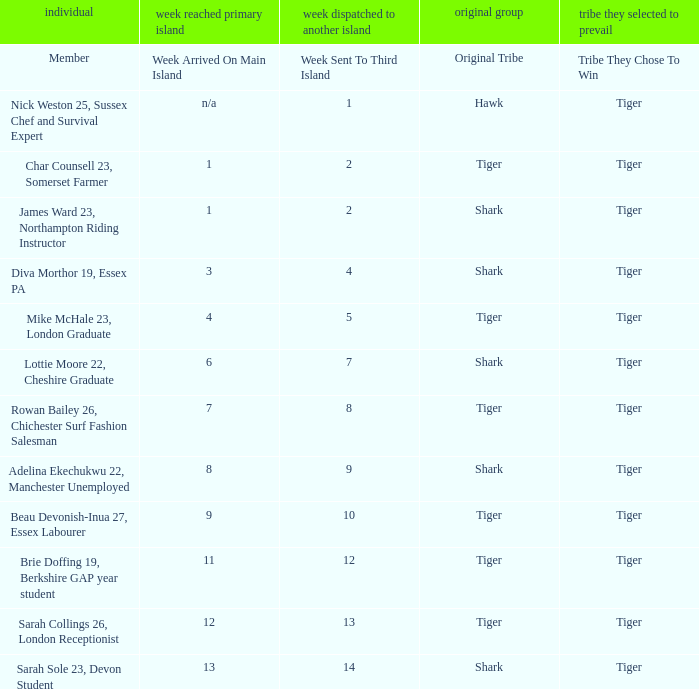What week did the member who's original tribe was shark and who was sent to the third island on week 14 arrive on the main island? 13.0. 